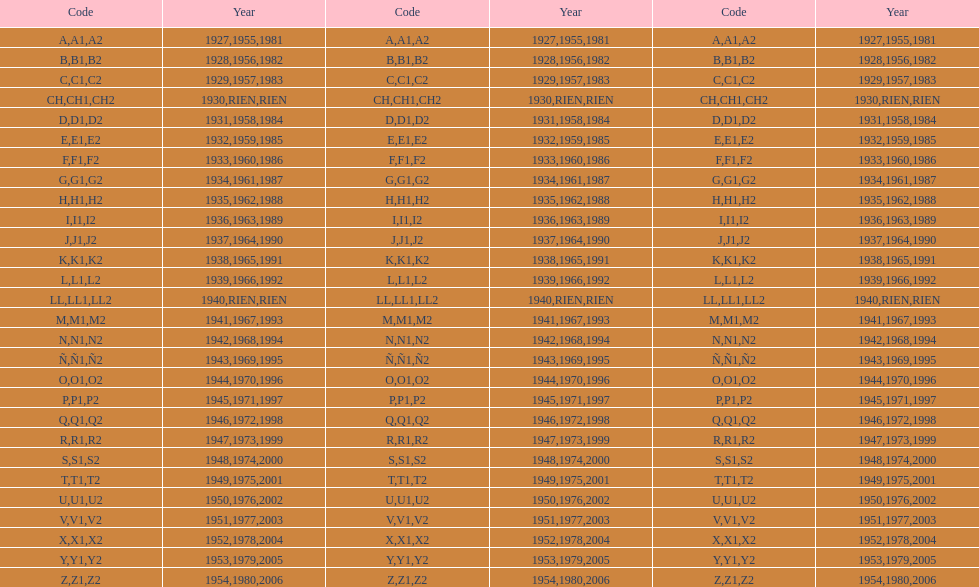List each code not associated to a year. CH1, CH2, LL1, LL2. 